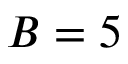Convert formula to latex. <formula><loc_0><loc_0><loc_500><loc_500>B = 5</formula> 